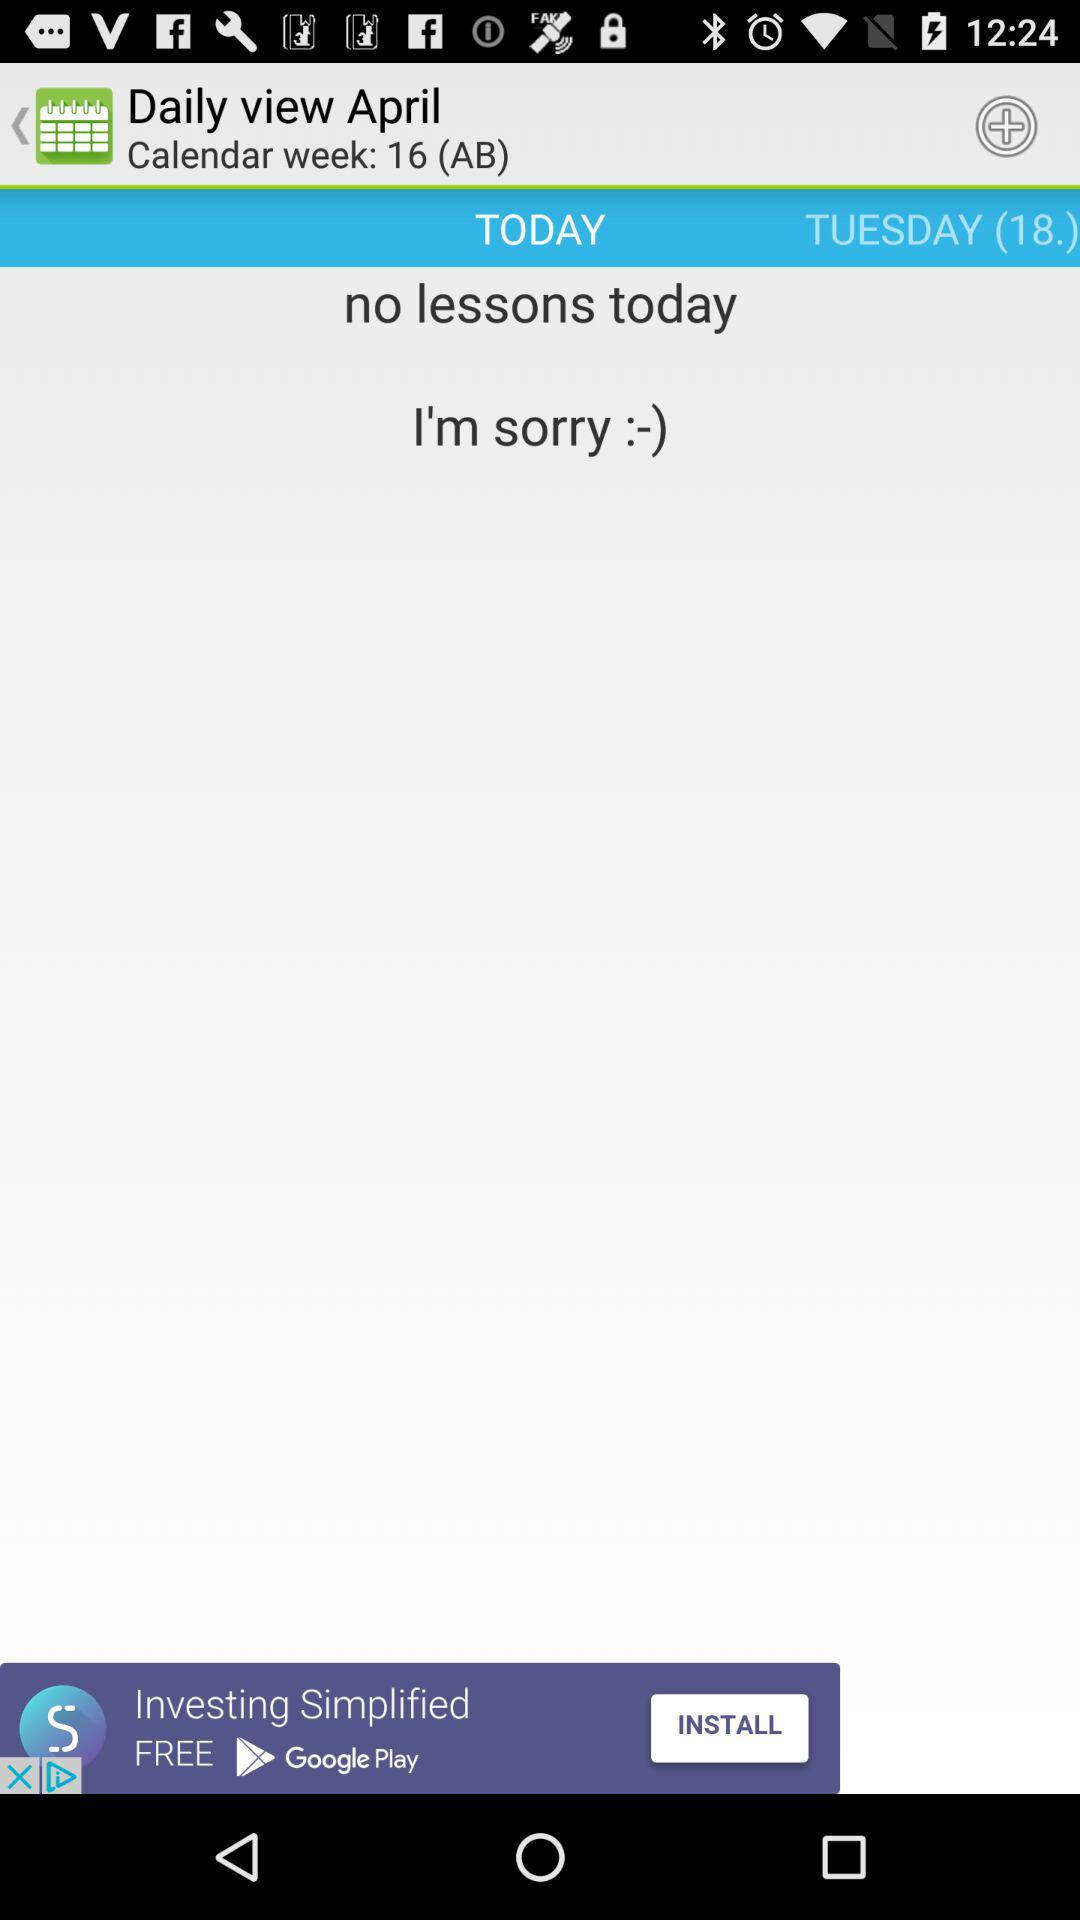What is the date today?
When the provided information is insufficient, respond with <no answer>. <no answer> 